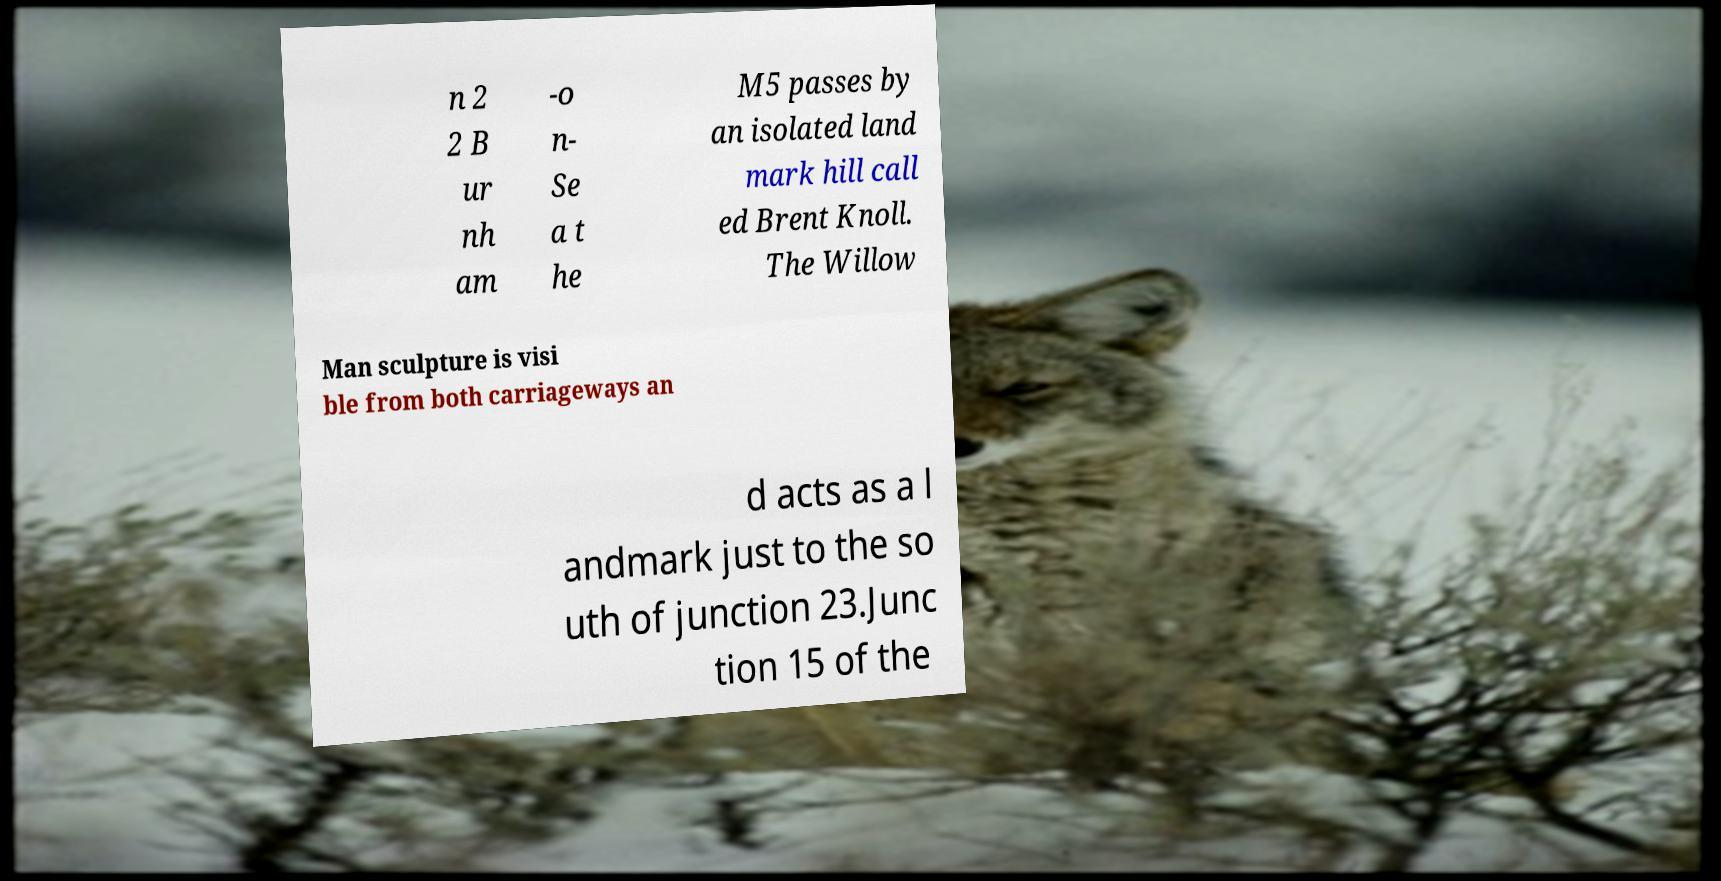Could you assist in decoding the text presented in this image and type it out clearly? n 2 2 B ur nh am -o n- Se a t he M5 passes by an isolated land mark hill call ed Brent Knoll. The Willow Man sculpture is visi ble from both carriageways an d acts as a l andmark just to the so uth of junction 23.Junc tion 15 of the 